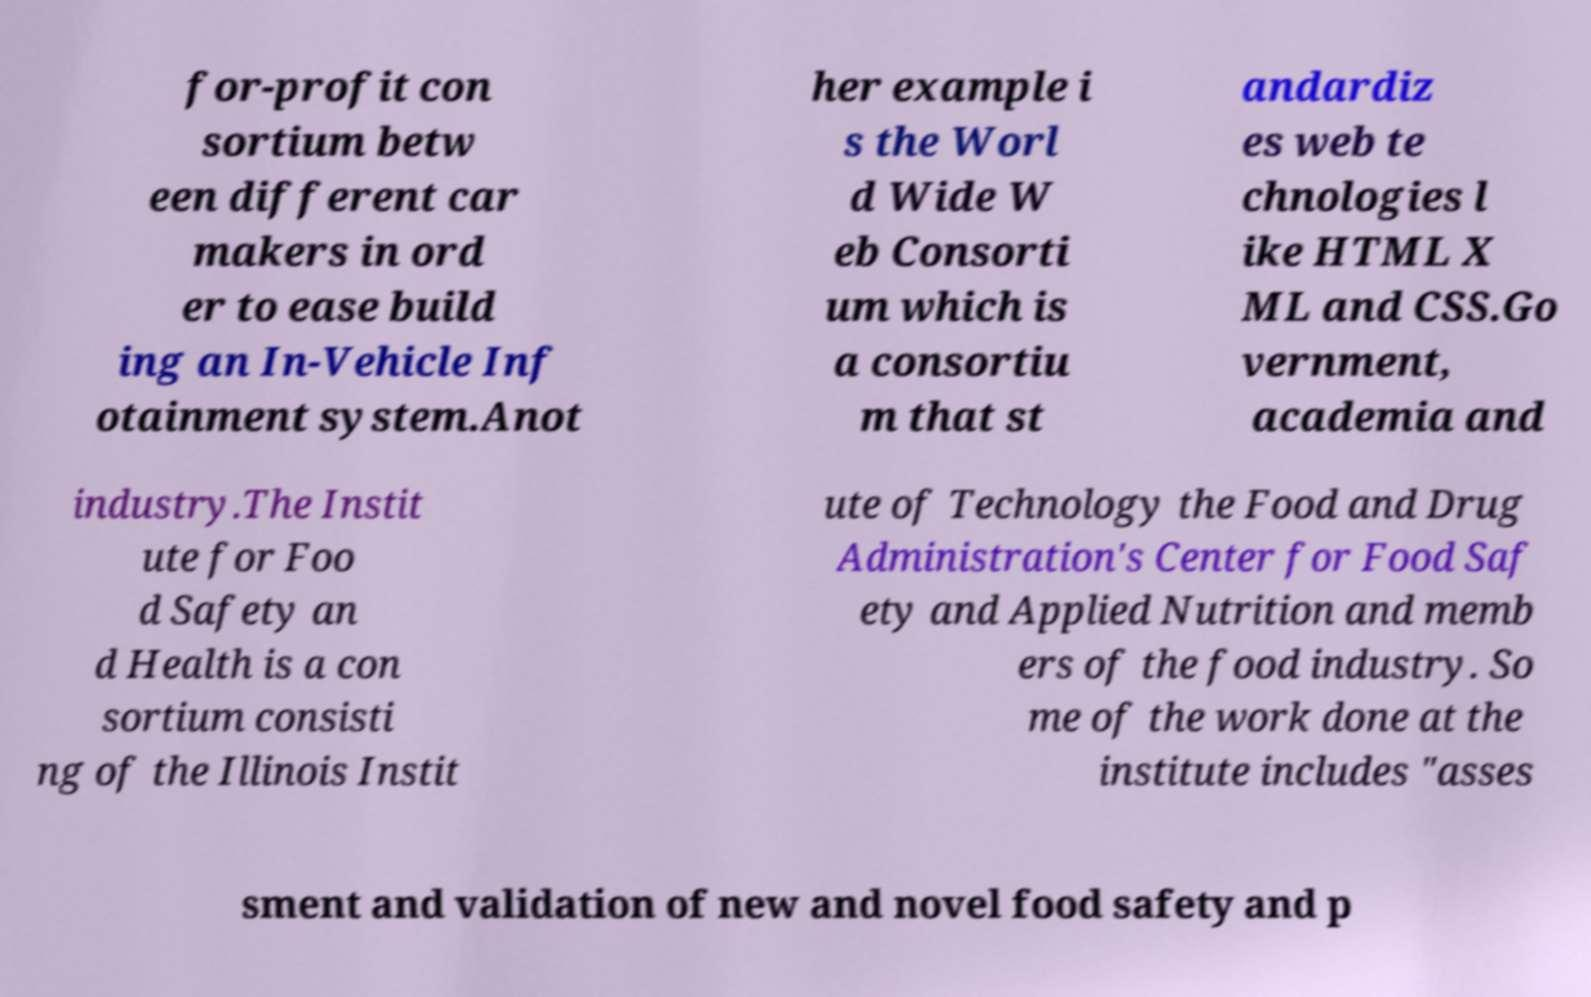Please identify and transcribe the text found in this image. for-profit con sortium betw een different car makers in ord er to ease build ing an In-Vehicle Inf otainment system.Anot her example i s the Worl d Wide W eb Consorti um which is a consortiu m that st andardiz es web te chnologies l ike HTML X ML and CSS.Go vernment, academia and industry.The Instit ute for Foo d Safety an d Health is a con sortium consisti ng of the Illinois Instit ute of Technology the Food and Drug Administration's Center for Food Saf ety and Applied Nutrition and memb ers of the food industry. So me of the work done at the institute includes "asses sment and validation of new and novel food safety and p 